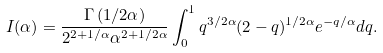<formula> <loc_0><loc_0><loc_500><loc_500>I ( \alpha ) = \frac { \Gamma \left ( 1 / 2 \alpha \right ) } { 2 ^ { 2 + 1 / \alpha } \alpha ^ { 2 + 1 / 2 \alpha } } \int _ { 0 } ^ { 1 } q ^ { 3 / 2 \alpha } ( 2 - q ) ^ { 1 / 2 \alpha } e ^ { - q / \alpha } d q .</formula> 